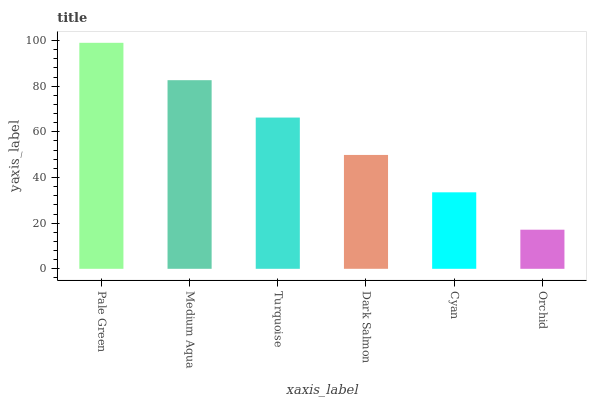Is Medium Aqua the minimum?
Answer yes or no. No. Is Medium Aqua the maximum?
Answer yes or no. No. Is Pale Green greater than Medium Aqua?
Answer yes or no. Yes. Is Medium Aqua less than Pale Green?
Answer yes or no. Yes. Is Medium Aqua greater than Pale Green?
Answer yes or no. No. Is Pale Green less than Medium Aqua?
Answer yes or no. No. Is Turquoise the high median?
Answer yes or no. Yes. Is Dark Salmon the low median?
Answer yes or no. Yes. Is Medium Aqua the high median?
Answer yes or no. No. Is Orchid the low median?
Answer yes or no. No. 